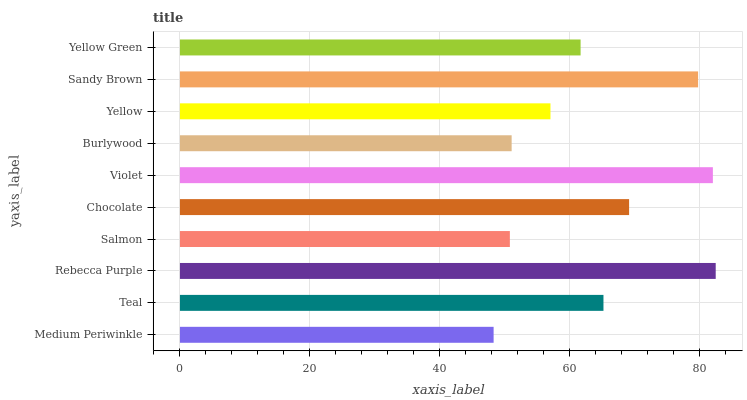Is Medium Periwinkle the minimum?
Answer yes or no. Yes. Is Rebecca Purple the maximum?
Answer yes or no. Yes. Is Teal the minimum?
Answer yes or no. No. Is Teal the maximum?
Answer yes or no. No. Is Teal greater than Medium Periwinkle?
Answer yes or no. Yes. Is Medium Periwinkle less than Teal?
Answer yes or no. Yes. Is Medium Periwinkle greater than Teal?
Answer yes or no. No. Is Teal less than Medium Periwinkle?
Answer yes or no. No. Is Teal the high median?
Answer yes or no. Yes. Is Yellow Green the low median?
Answer yes or no. Yes. Is Rebecca Purple the high median?
Answer yes or no. No. Is Salmon the low median?
Answer yes or no. No. 